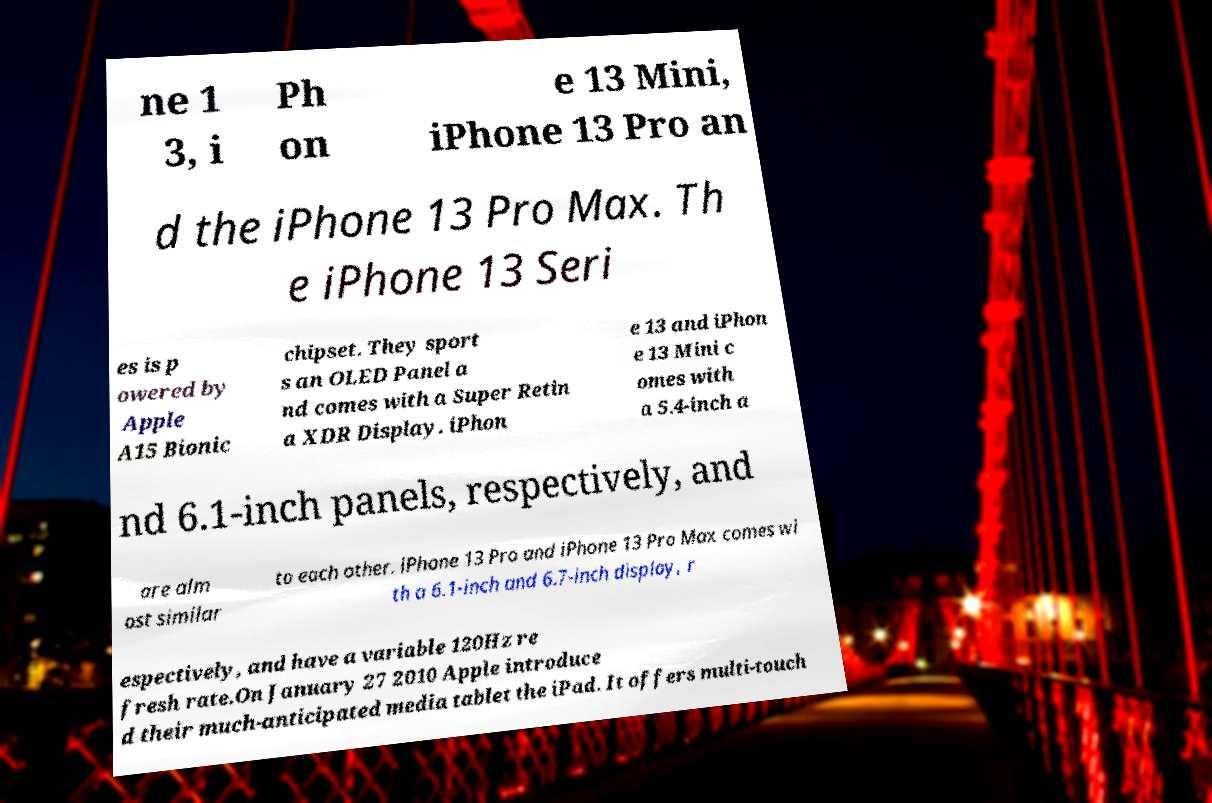Can you accurately transcribe the text from the provided image for me? ne 1 3, i Ph on e 13 Mini, iPhone 13 Pro an d the iPhone 13 Pro Max. Th e iPhone 13 Seri es is p owered by Apple A15 Bionic chipset. They sport s an OLED Panel a nd comes with a Super Retin a XDR Display. iPhon e 13 and iPhon e 13 Mini c omes with a 5.4-inch a nd 6.1-inch panels, respectively, and are alm ost similar to each other. iPhone 13 Pro and iPhone 13 Pro Max comes wi th a 6.1-inch and 6.7-inch display, r espectively, and have a variable 120Hz re fresh rate.On January 27 2010 Apple introduce d their much-anticipated media tablet the iPad. It offers multi-touch 